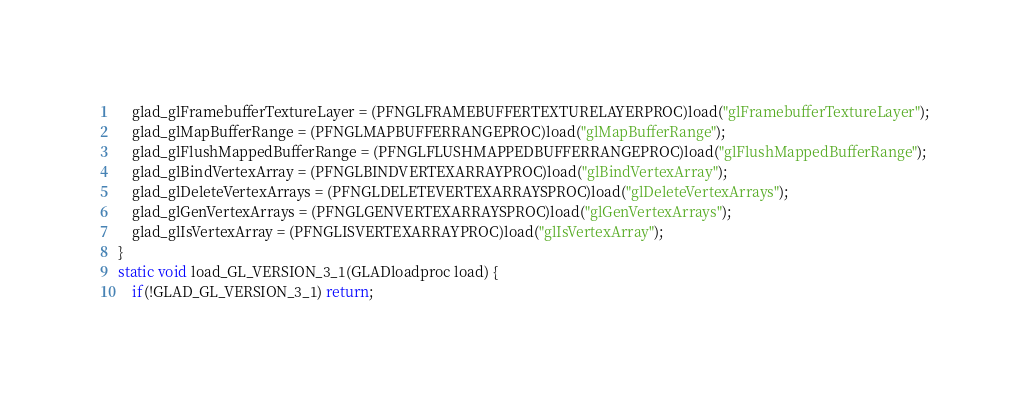Convert code to text. <code><loc_0><loc_0><loc_500><loc_500><_C_>	glad_glFramebufferTextureLayer = (PFNGLFRAMEBUFFERTEXTURELAYERPROC)load("glFramebufferTextureLayer");
	glad_glMapBufferRange = (PFNGLMAPBUFFERRANGEPROC)load("glMapBufferRange");
	glad_glFlushMappedBufferRange = (PFNGLFLUSHMAPPEDBUFFERRANGEPROC)load("glFlushMappedBufferRange");
	glad_glBindVertexArray = (PFNGLBINDVERTEXARRAYPROC)load("glBindVertexArray");
	glad_glDeleteVertexArrays = (PFNGLDELETEVERTEXARRAYSPROC)load("glDeleteVertexArrays");
	glad_glGenVertexArrays = (PFNGLGENVERTEXARRAYSPROC)load("glGenVertexArrays");
	glad_glIsVertexArray = (PFNGLISVERTEXARRAYPROC)load("glIsVertexArray");
}
static void load_GL_VERSION_3_1(GLADloadproc load) {
	if(!GLAD_GL_VERSION_3_1) return;</code> 